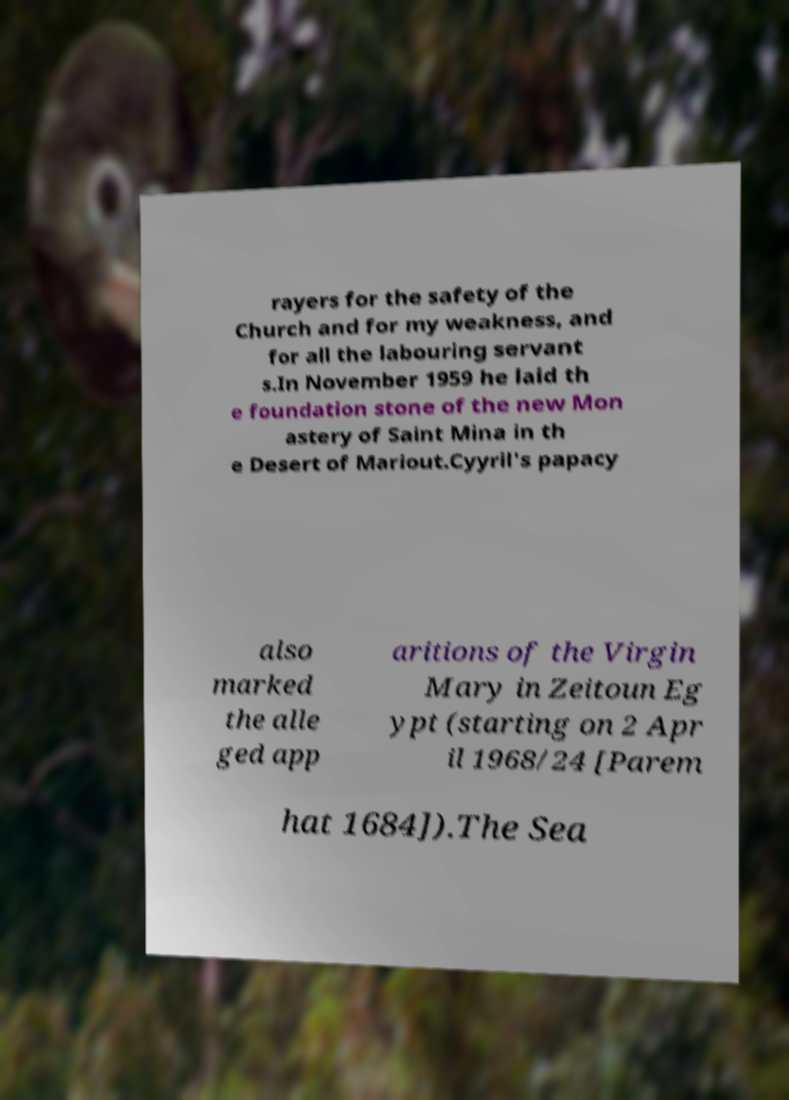For documentation purposes, I need the text within this image transcribed. Could you provide that? rayers for the safety of the Church and for my weakness, and for all the labouring servant s.In November 1959 he laid th e foundation stone of the new Mon astery of Saint Mina in th e Desert of Mariout.Cyyril's papacy also marked the alle ged app aritions of the Virgin Mary in Zeitoun Eg ypt (starting on 2 Apr il 1968/24 [Parem hat 1684]).The Sea 